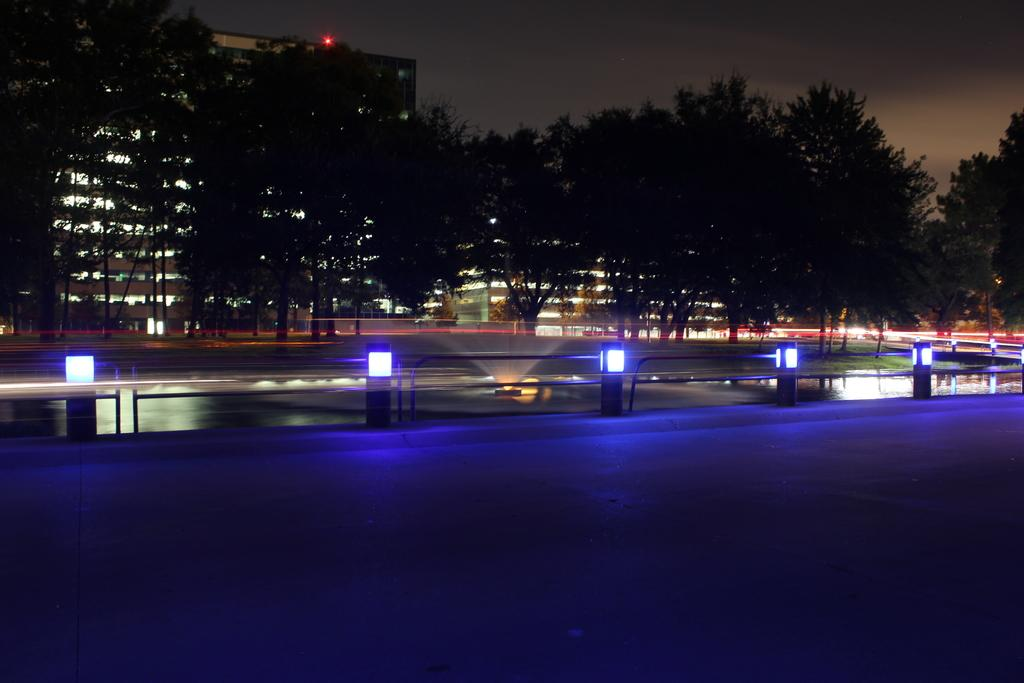What is the main feature of the image? There is a road in the image. What can be seen on the road? There are black colored poles with lights in the image. What other features are present in the image? There is a fountain and trees in the image. What can be seen in the background of the image? There are buildings and the sky visible in the background of the image. Can you see a cap floating in the fountain in the image? There is no cap present in the image, and it does not show any objects floating in the fountain. Is there a boat navigating through the quicksand in the image? There is no boat or quicksand present in the image; it features a road, black poles with lights, a fountain, trees, buildings, and the sky. 